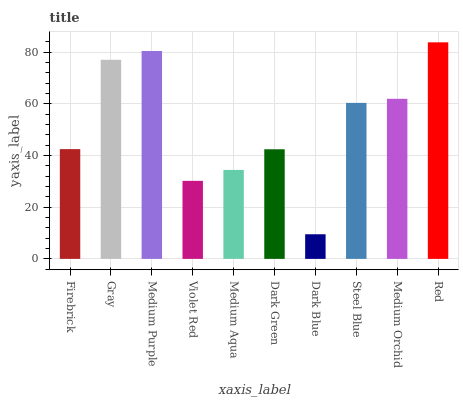Is Dark Blue the minimum?
Answer yes or no. Yes. Is Red the maximum?
Answer yes or no. Yes. Is Gray the minimum?
Answer yes or no. No. Is Gray the maximum?
Answer yes or no. No. Is Gray greater than Firebrick?
Answer yes or no. Yes. Is Firebrick less than Gray?
Answer yes or no. Yes. Is Firebrick greater than Gray?
Answer yes or no. No. Is Gray less than Firebrick?
Answer yes or no. No. Is Steel Blue the high median?
Answer yes or no. Yes. Is Firebrick the low median?
Answer yes or no. Yes. Is Violet Red the high median?
Answer yes or no. No. Is Steel Blue the low median?
Answer yes or no. No. 